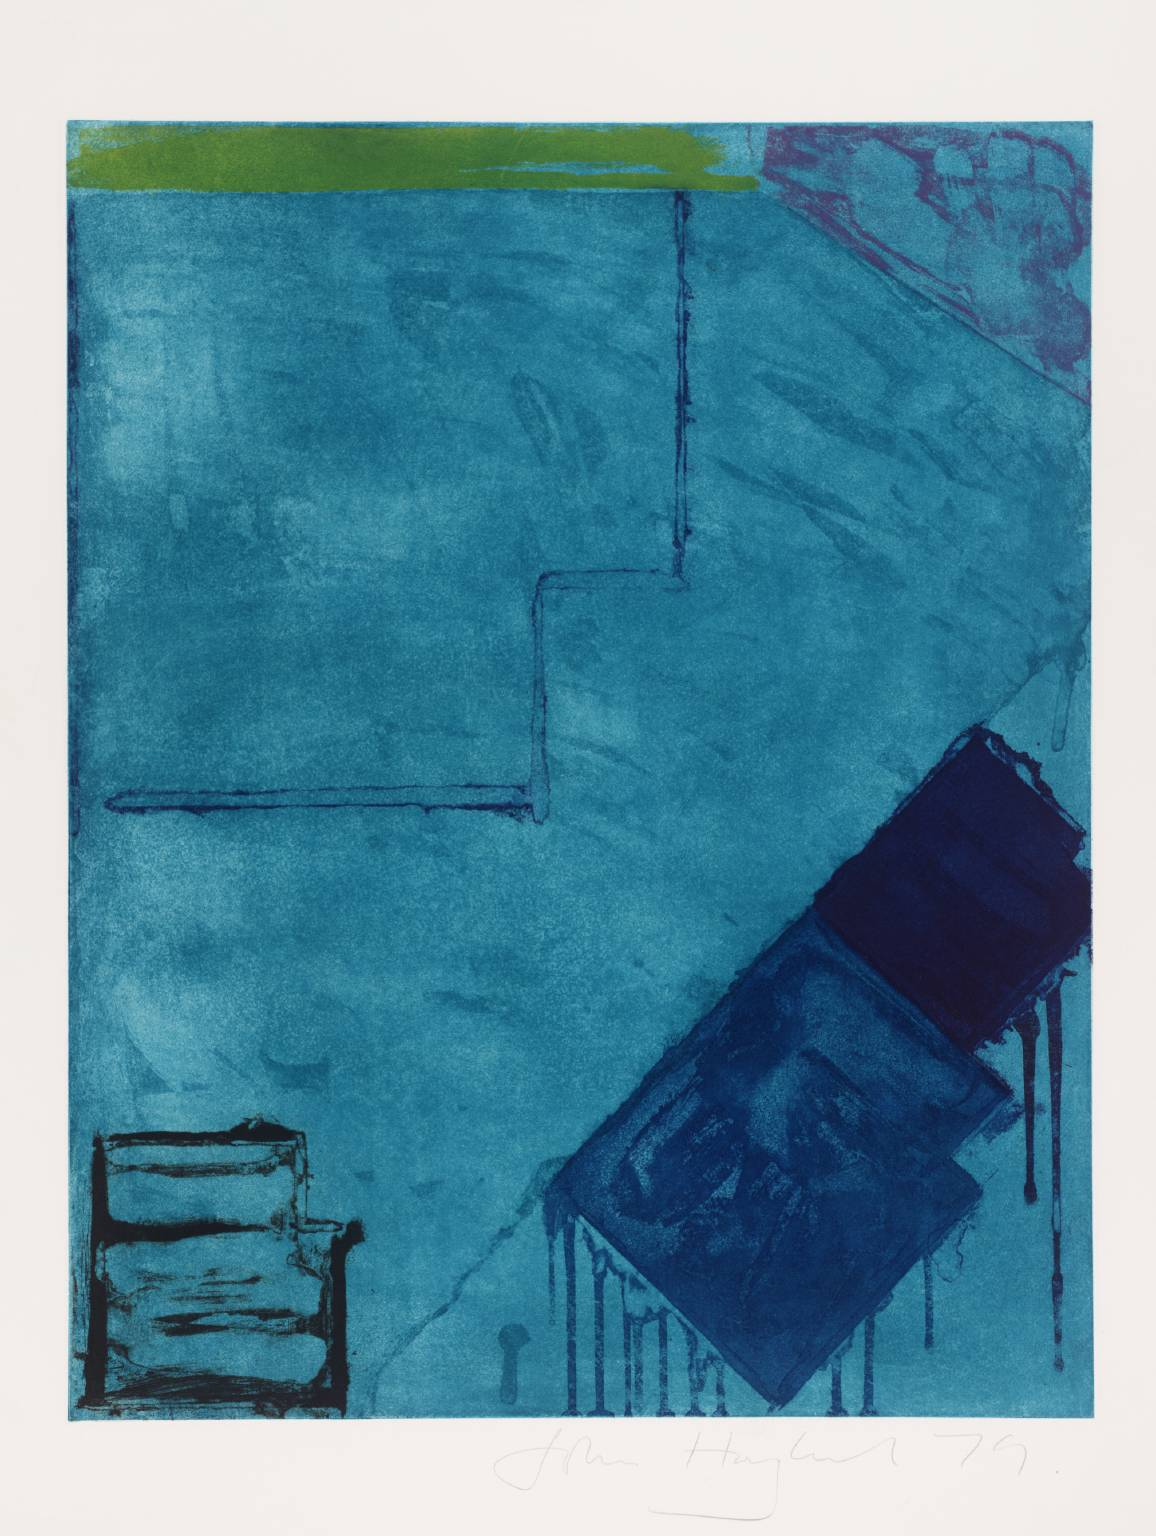What mood does the combination of colors in the artwork convey? The combination of deep blues with highlights of green and pinkish-red in the artwork conveys a mood of contemplation and depth. Blue often evokes feelings of calmness and serenity, but the inclusion of vibrant contrasting colors adds a layer of complexity and emotional intensity. This mood might suggest a reflective or introspective state, inviting the viewer to delve deeper into their own thoughts or feelings while engaging with the piece. 